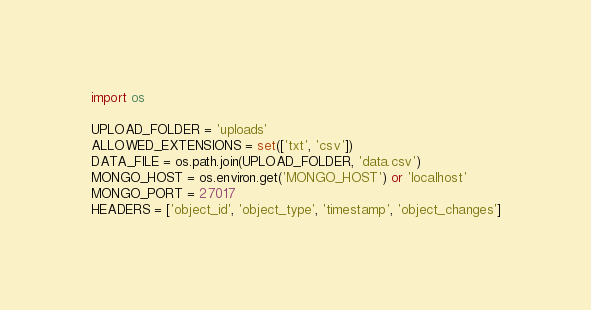<code> <loc_0><loc_0><loc_500><loc_500><_Python_>import os

UPLOAD_FOLDER = 'uploads'
ALLOWED_EXTENSIONS = set(['txt', 'csv'])
DATA_FILE = os.path.join(UPLOAD_FOLDER, 'data.csv')
MONGO_HOST = os.environ.get('MONGO_HOST') or 'localhost'
MONGO_PORT = 27017
HEADERS = ['object_id', 'object_type', 'timestamp', 'object_changes']</code> 